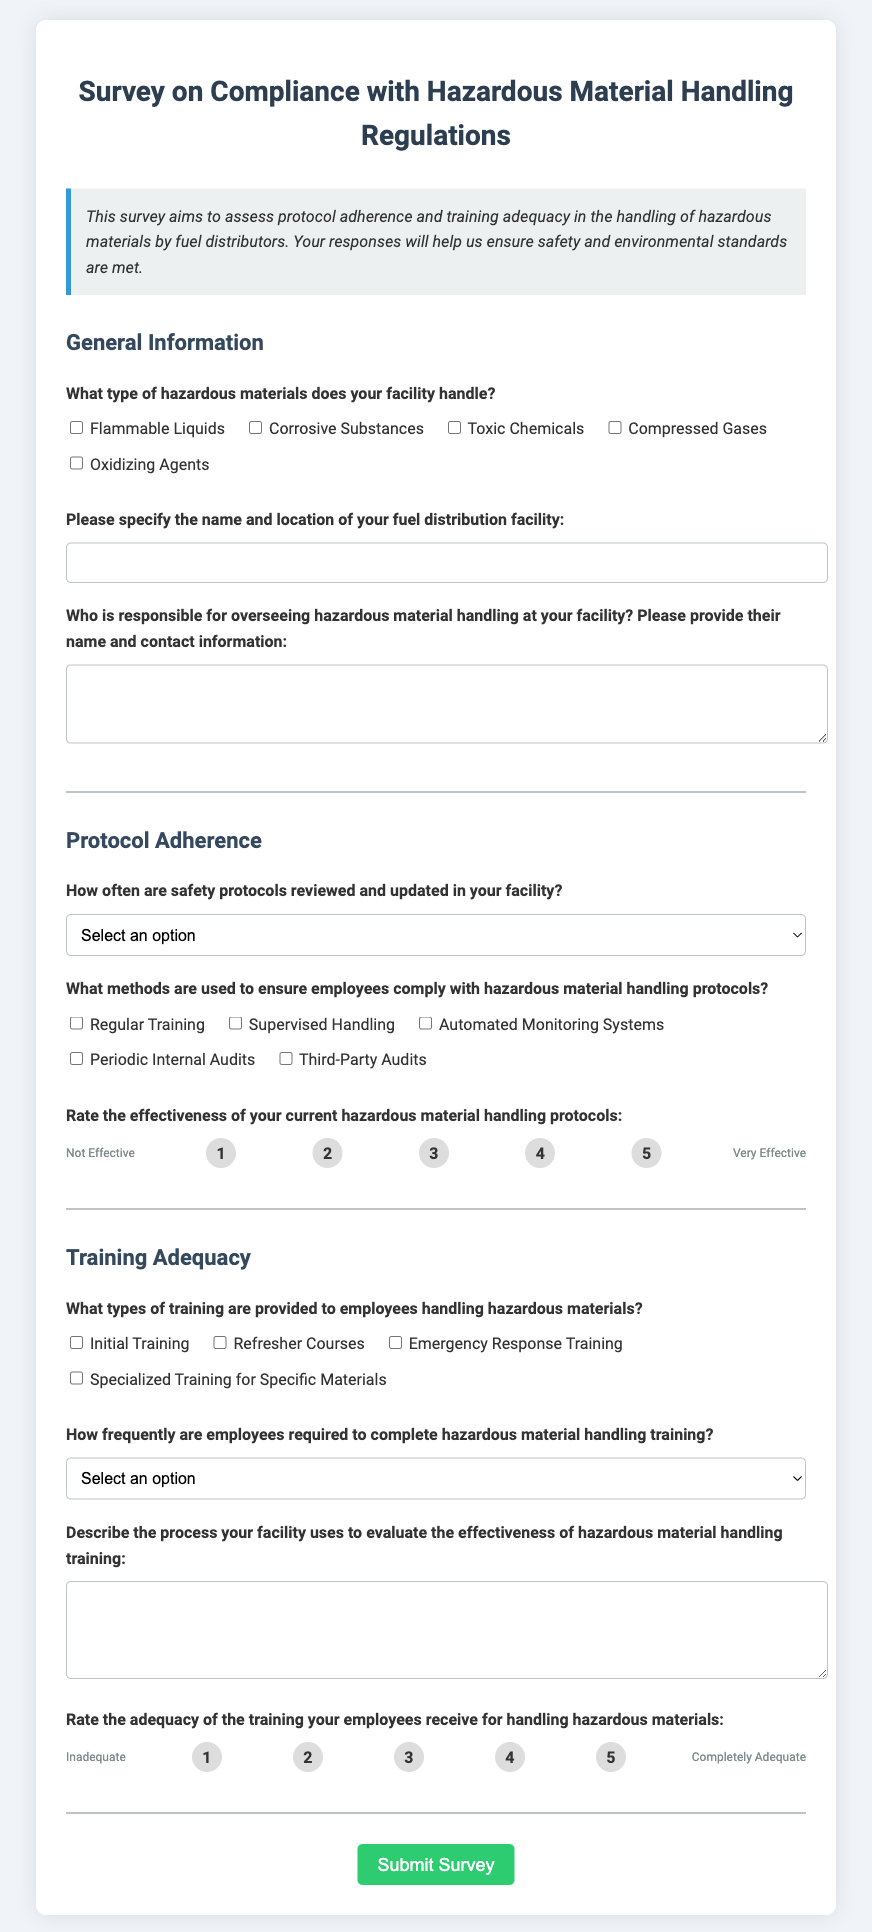What type of hazardous materials does the facility handle? The document lists various hazardous materials that facilities may handle, such as Flammable Liquids, Corrosive Substances, Toxic Chemicals, Compressed Gases, and Oxidizing Agents.
Answer: Flammable Liquids, Corrosive Substances, Toxic Chemicals, Compressed Gases, Oxidizing Agents Who is responsible for overseeing hazardous material handling at the facility? The document asks for the name and contact information of the responsible person overseeing hazardous material handling, indicating that this information must be provided by the respondent.
Answer: Name and contact information of responsible person How frequently are safety protocols reviewed in the facility? The document mentions review frequencies such as Monthly, Quarterly, Annually, and Whenever regulations change as options for this question.
Answer: Monthly, Quarterly, Annually, or Whenever regulations change What types of training are provided to employees handling hazardous materials? The document outlines training types like Initial Training, Refresher Courses, Emergency Response Training, and Specialized Training for Specific Materials that could be selected.
Answer: Initial Training, Refresher Courses, Emergency Response Training, Specialized Training Rate the effectiveness of current hazardous material handling protocols on a scale from 1 to 5. The document includes a section where respondents can rate the effectiveness of their handling protocols, with labeled options from 1 (Not Effective) to 5 (Very Effective).
Answer: 1 to 5 How often are employees required to complete hazardous material handling training? The response options provided in the document include Monthly, Quarterly, Semi-Annually, Annually, or As Needed for training frequency.
Answer: Monthly, Quarterly, Semi-Annually, Annually, or As Needed What are the methods used to ensure compliance with hazardous material handling protocols? The document lists methods like Regular Training, Supervised Handling, Automated Monitoring Systems, Periodic Internal Audits, and Third-Party Audits as potential responses.
Answer: Regular Training, Supervised Handling, Automated Monitoring Systems, Periodic Internal Audits, Third-Party Audits Describe the process used to evaluate the effectiveness of hazardous material handling training. The document requires a descriptive response about the evaluation process for hazardous material handling training, indicating that the respondent should provide their specific methods.
Answer: Descriptive process of evaluation What rating is given for the adequacy of the training received for handling hazardous materials? The document provides a scale for rating training adequacy from 1 (Inadequate) to 5 (Completely Adequate).
Answer: 1 to 5 